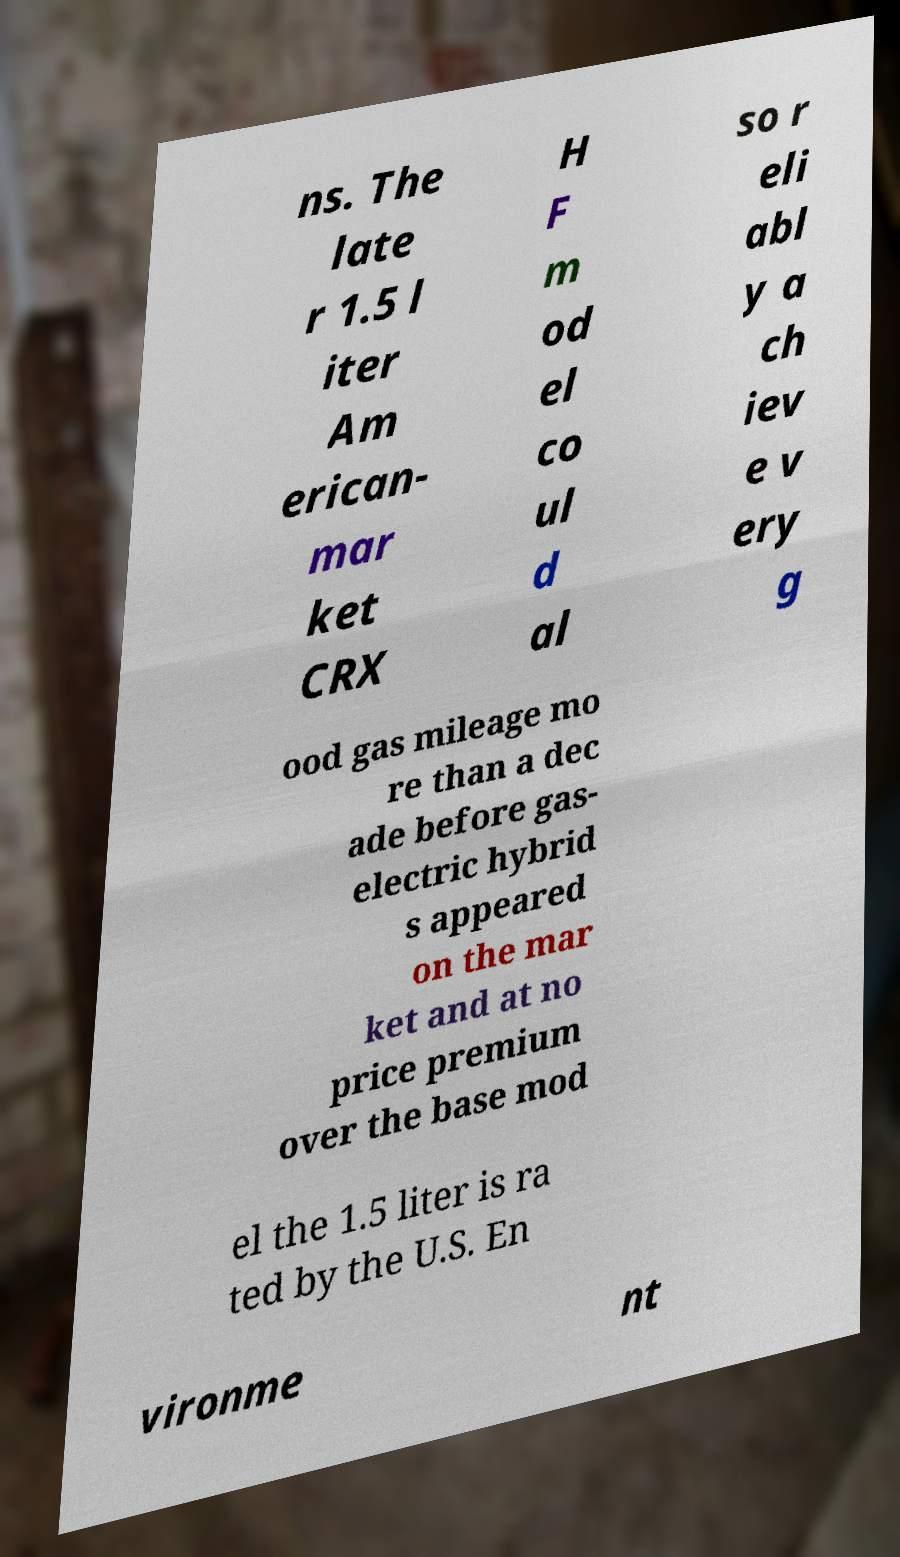What messages or text are displayed in this image? I need them in a readable, typed format. ns. The late r 1.5 l iter Am erican- mar ket CRX H F m od el co ul d al so r eli abl y a ch iev e v ery g ood gas mileage mo re than a dec ade before gas- electric hybrid s appeared on the mar ket and at no price premium over the base mod el the 1.5 liter is ra ted by the U.S. En vironme nt 